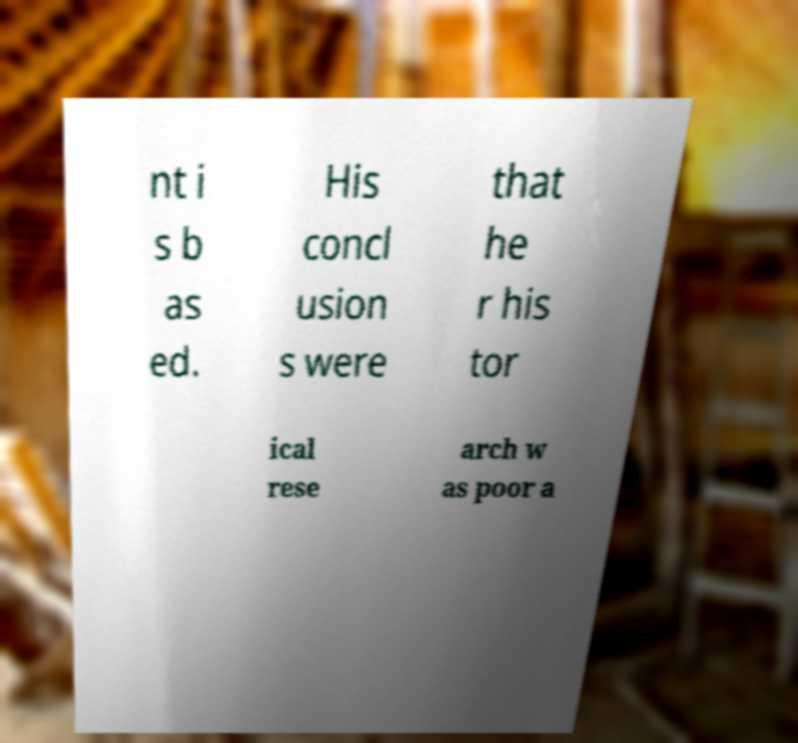For documentation purposes, I need the text within this image transcribed. Could you provide that? nt i s b as ed. His concl usion s were that he r his tor ical rese arch w as poor a 